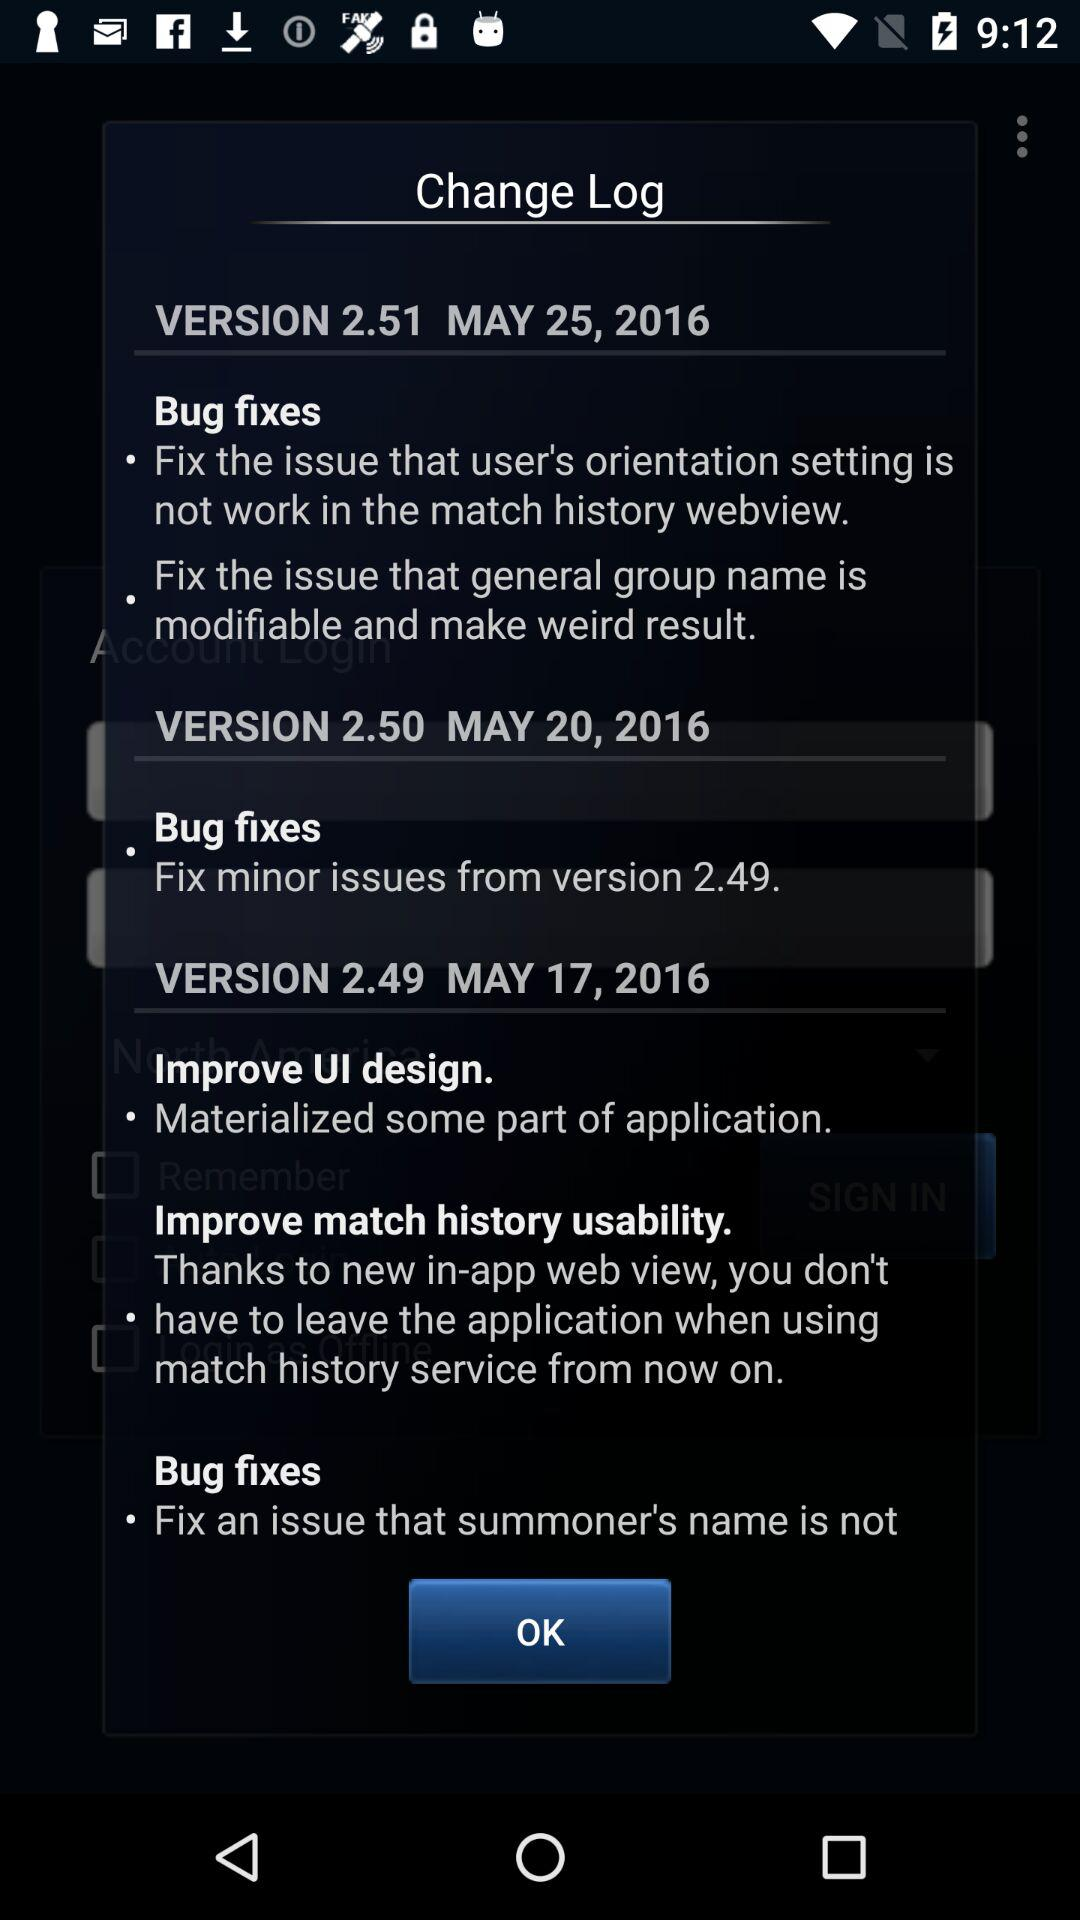What is the latest version? The latest version is 2.51. 